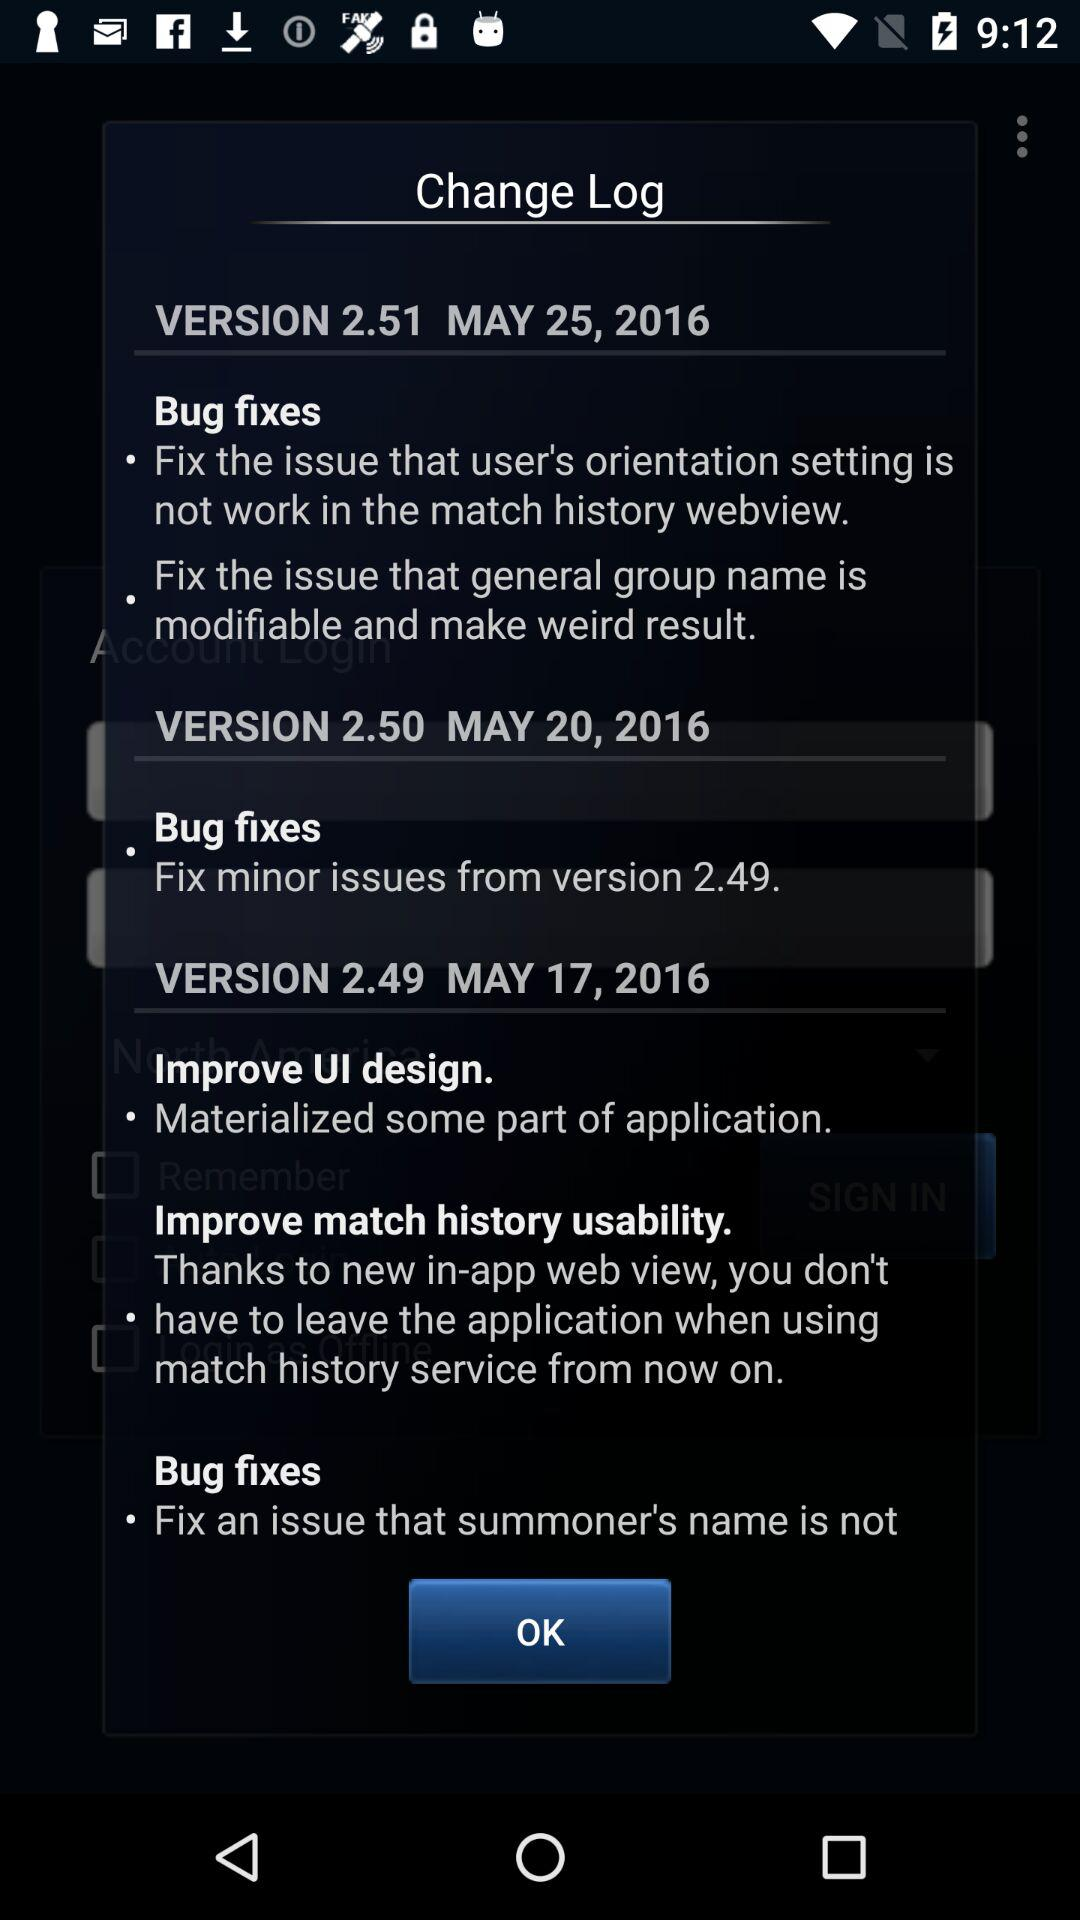What is the latest version? The latest version is 2.51. 